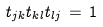<formula> <loc_0><loc_0><loc_500><loc_500>t _ { j k } t _ { k l } t _ { l j } \, = \, 1</formula> 